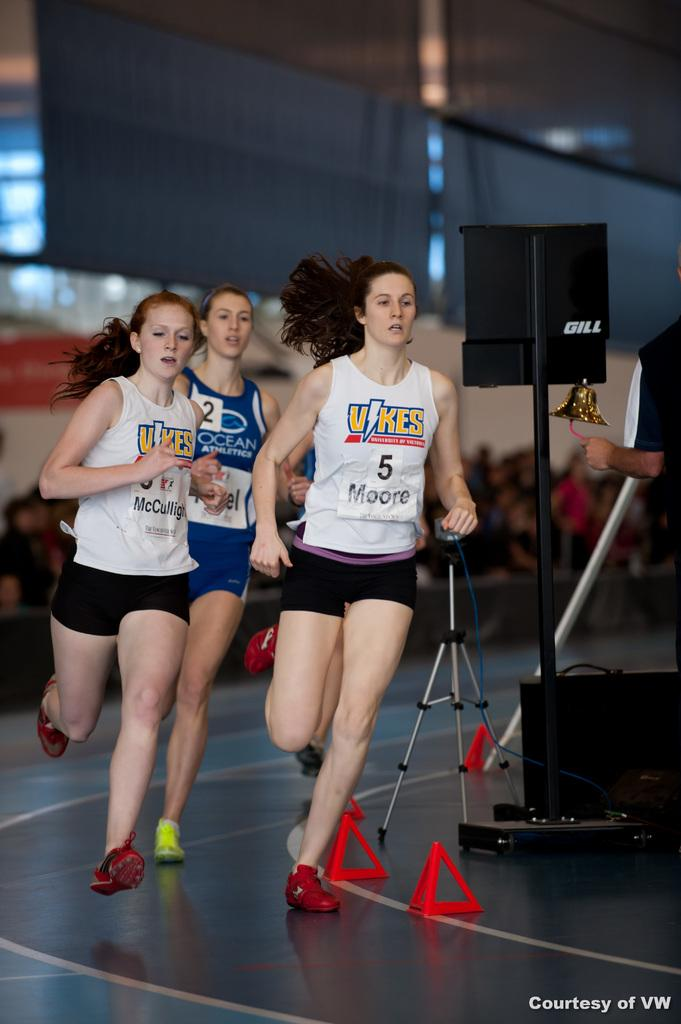<image>
Describe the image concisely. Three girls are running at a track meet with shirts that say Vikes. 